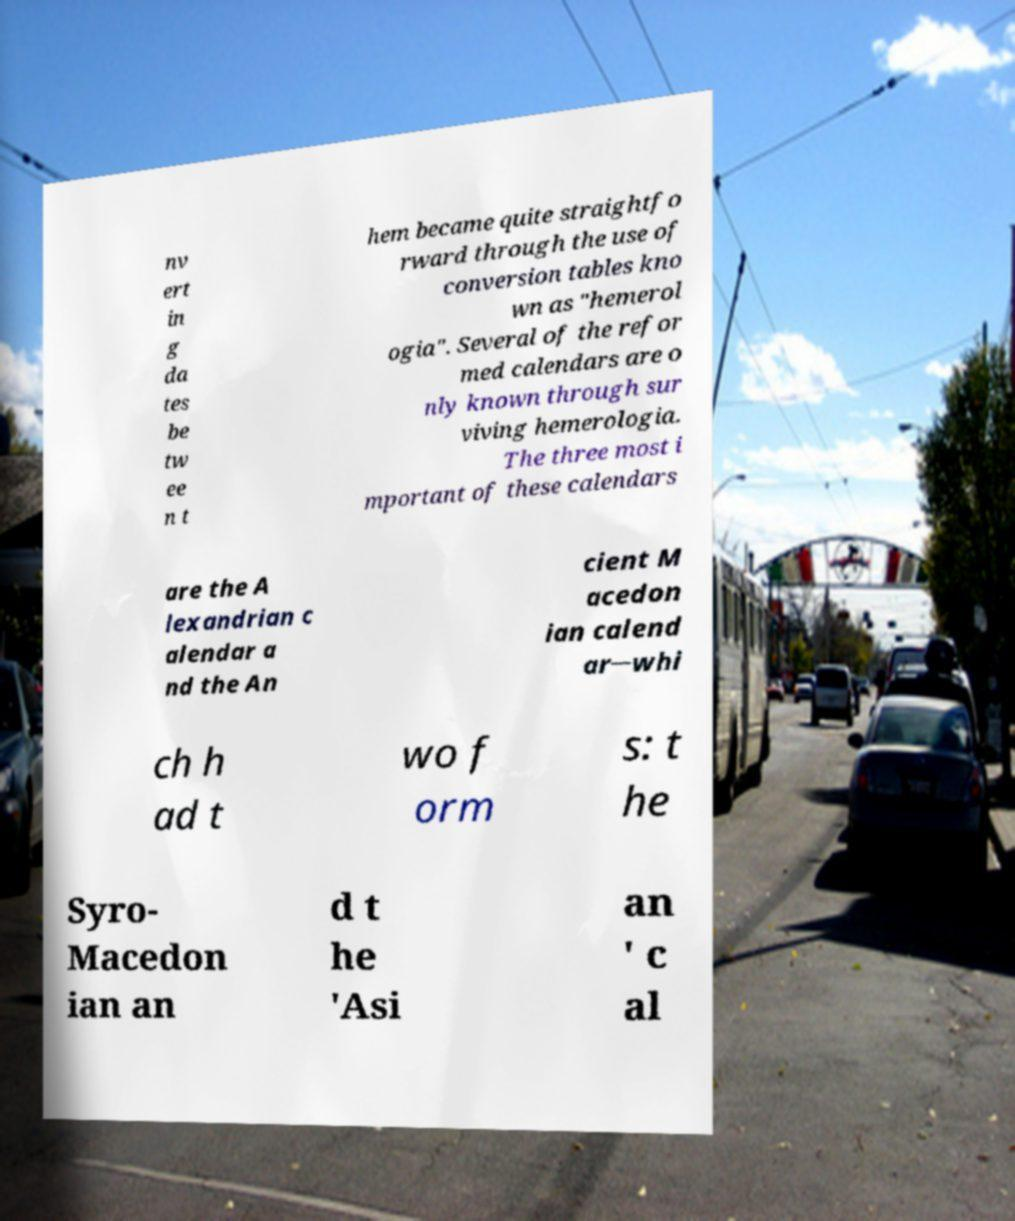Could you extract and type out the text from this image? nv ert in g da tes be tw ee n t hem became quite straightfo rward through the use of conversion tables kno wn as "hemerol ogia". Several of the refor med calendars are o nly known through sur viving hemerologia. The three most i mportant of these calendars are the A lexandrian c alendar a nd the An cient M acedon ian calend ar─whi ch h ad t wo f orm s: t he Syro- Macedon ian an d t he 'Asi an ' c al 